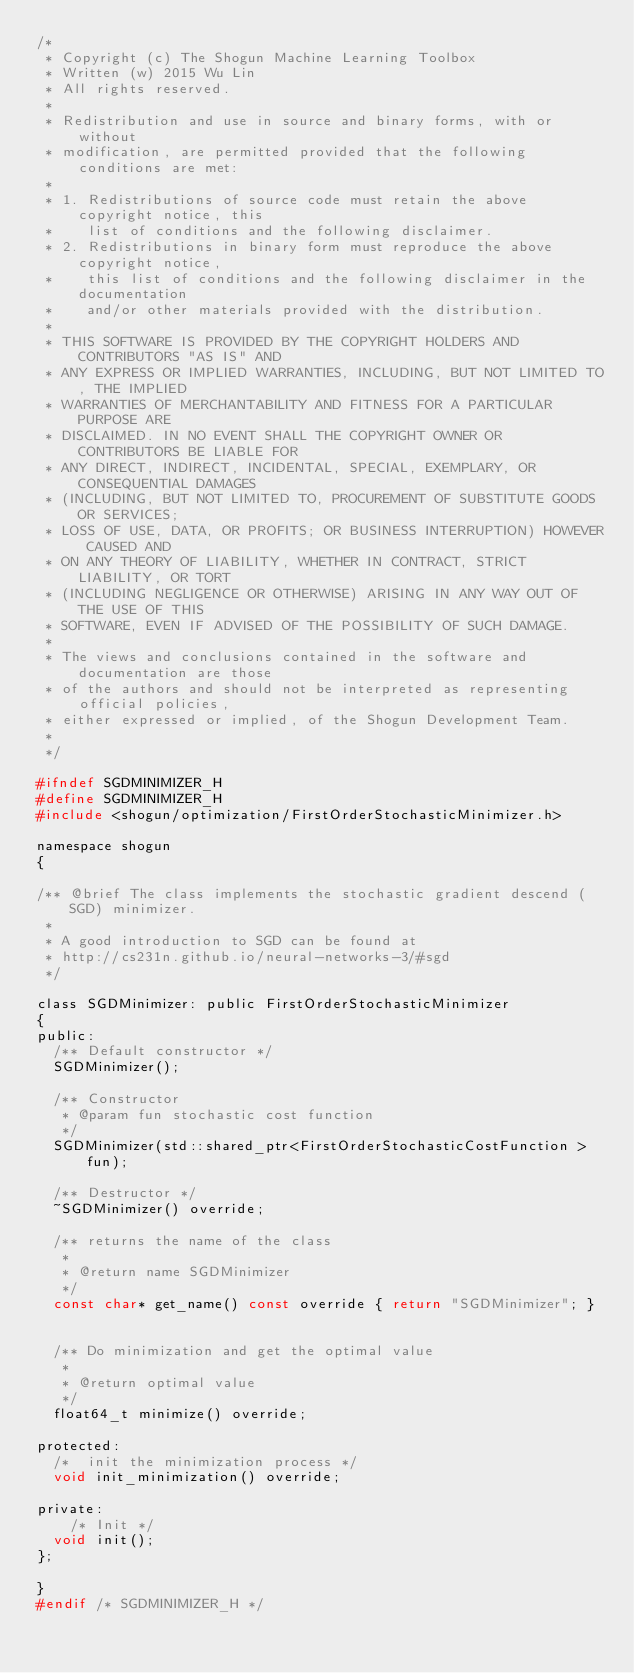<code> <loc_0><loc_0><loc_500><loc_500><_C_>/*
 * Copyright (c) The Shogun Machine Learning Toolbox
 * Written (w) 2015 Wu Lin
 * All rights reserved.
 *
 * Redistribution and use in source and binary forms, with or without
 * modification, are permitted provided that the following conditions are met:
 *
 * 1. Redistributions of source code must retain the above copyright notice, this
 *    list of conditions and the following disclaimer.
 * 2. Redistributions in binary form must reproduce the above copyright notice,
 *    this list of conditions and the following disclaimer in the documentation
 *    and/or other materials provided with the distribution.
 *
 * THIS SOFTWARE IS PROVIDED BY THE COPYRIGHT HOLDERS AND CONTRIBUTORS "AS IS" AND
 * ANY EXPRESS OR IMPLIED WARRANTIES, INCLUDING, BUT NOT LIMITED TO, THE IMPLIED
 * WARRANTIES OF MERCHANTABILITY AND FITNESS FOR A PARTICULAR PURPOSE ARE
 * DISCLAIMED. IN NO EVENT SHALL THE COPYRIGHT OWNER OR CONTRIBUTORS BE LIABLE FOR
 * ANY DIRECT, INDIRECT, INCIDENTAL, SPECIAL, EXEMPLARY, OR CONSEQUENTIAL DAMAGES
 * (INCLUDING, BUT NOT LIMITED TO, PROCUREMENT OF SUBSTITUTE GOODS OR SERVICES;
 * LOSS OF USE, DATA, OR PROFITS; OR BUSINESS INTERRUPTION) HOWEVER CAUSED AND
 * ON ANY THEORY OF LIABILITY, WHETHER IN CONTRACT, STRICT LIABILITY, OR TORT
 * (INCLUDING NEGLIGENCE OR OTHERWISE) ARISING IN ANY WAY OUT OF THE USE OF THIS
 * SOFTWARE, EVEN IF ADVISED OF THE POSSIBILITY OF SUCH DAMAGE.
 *
 * The views and conclusions contained in the software and documentation are those
 * of the authors and should not be interpreted as representing official policies,
 * either expressed or implied, of the Shogun Development Team.
 *
 */

#ifndef SGDMINIMIZER_H
#define SGDMINIMIZER_H
#include <shogun/optimization/FirstOrderStochasticMinimizer.h>

namespace shogun
{

/** @brief The class implements the stochastic gradient descend (SGD) minimizer.
 *
 * A good introduction to SGD can be found at
 * http://cs231n.github.io/neural-networks-3/#sgd
 */

class SGDMinimizer: public FirstOrderStochasticMinimizer
{
public:
	/** Default constructor */
	SGDMinimizer();

	/** Constructor
	 * @param fun stochastic cost function
	 */
	SGDMinimizer(std::shared_ptr<FirstOrderStochasticCostFunction >fun);

	/** Destructor */
	~SGDMinimizer() override;

	/** returns the name of the class
	 *
	 * @return name SGDMinimizer
	 */
	const char* get_name() const override { return "SGDMinimizer"; }


	/** Do minimization and get the optimal value 
	 * 
	 * @return optimal value
	 */
	float64_t minimize() override;

protected:
	/*  init the minimization process */
	void init_minimization() override;

private:
	  /* Init */
	void init();
};

}
#endif /* SGDMINIMIZER_H */
</code> 